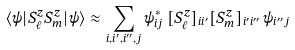Convert formula to latex. <formula><loc_0><loc_0><loc_500><loc_500>\langle \psi | S ^ { z } _ { \ell } S ^ { z } _ { m } | \psi \rangle \approx \sum _ { i , i ^ { \prime } , i ^ { \prime \prime } , j } \psi ^ { * } _ { i j } \, [ S ^ { z } _ { \ell } ] _ { i i ^ { \prime } } [ S ^ { z } _ { m } ] _ { i ^ { \prime } i ^ { \prime \prime } } \, \psi _ { i ^ { \prime \prime } j }</formula> 